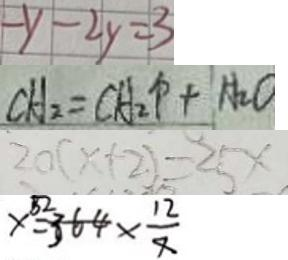<formula> <loc_0><loc_0><loc_500><loc_500>- y - 2 y = 3 
 C H _ { 2 } = C H _ { 2 } \uparrow + H _ { 2 } O 
 2 0 ( x + 2 ) = 2 5 x 
 x = 3 6 4 \times \frac { 1 2 } { 7 }</formula> 